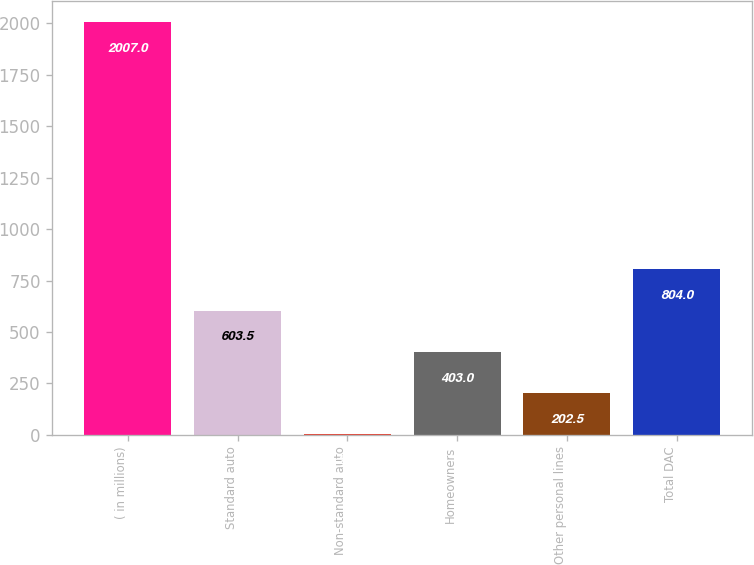Convert chart. <chart><loc_0><loc_0><loc_500><loc_500><bar_chart><fcel>( in millions)<fcel>Standard auto<fcel>Non-standard auto<fcel>Homeowners<fcel>Other personal lines<fcel>Total DAC<nl><fcel>2007<fcel>603.5<fcel>2<fcel>403<fcel>202.5<fcel>804<nl></chart> 